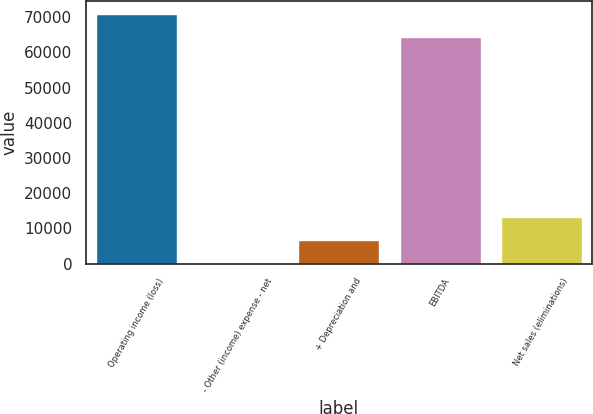<chart> <loc_0><loc_0><loc_500><loc_500><bar_chart><fcel>Operating income (loss)<fcel>- Other (income) expense - net<fcel>+ Depreciation and<fcel>EBITDA<fcel>Net sales (eliminations)<nl><fcel>70975.6<fcel>223<fcel>6707.6<fcel>64491<fcel>13192.2<nl></chart> 